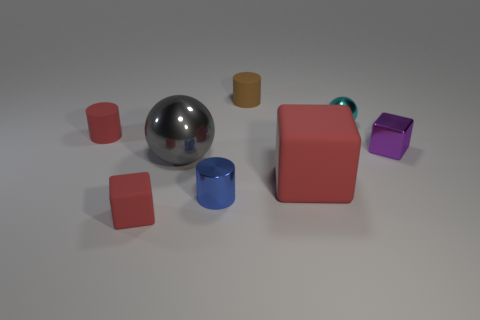What number of blue things are the same material as the large ball?
Offer a very short reply. 1. There is a rubber cylinder that is behind the tiny cyan metal thing; what number of tiny metallic blocks are behind it?
Offer a very short reply. 0. Are there any small matte cylinders to the right of the big ball?
Provide a short and direct response. Yes. Do the tiny red thing that is in front of the large matte cube and the tiny purple metallic object have the same shape?
Your response must be concise. Yes. There is a small cylinder that is the same color as the large matte block; what material is it?
Your response must be concise. Rubber. How many big objects are the same color as the big sphere?
Your answer should be compact. 0. What shape is the small rubber object left of the small red object in front of the purple metal object?
Provide a short and direct response. Cylinder. Are there any brown shiny things of the same shape as the big gray object?
Your answer should be very brief. No. Does the tiny metal cylinder have the same color as the matte cylinder behind the tiny metal ball?
Your answer should be compact. No. There is a cylinder that is the same color as the large matte cube; what size is it?
Your response must be concise. Small. 